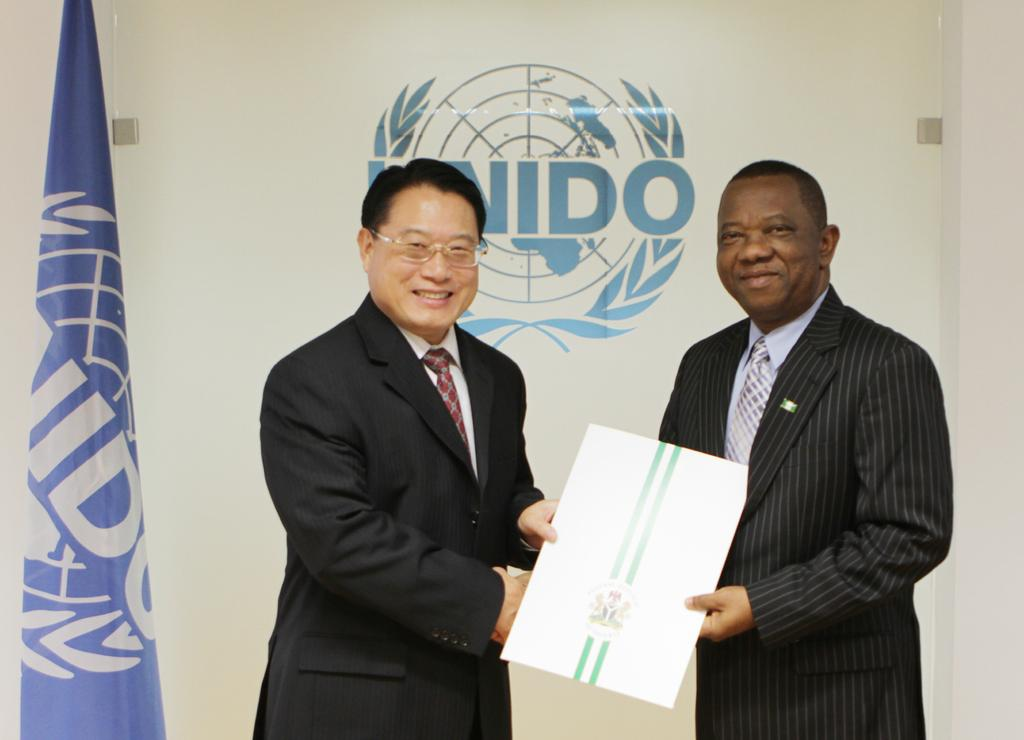How many people are in the image? There are two persons in the image. What are the persons holding in the image? Both persons are holding a paper. What can be seen beside the two persons? There is a flag beside the two persons. What is visible on the wall behind the persons? There is text and an image visible on the wall behind the persons. What type of drink is being served in the cave in the image? There is no cave or drink present in the image. 